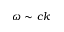Convert formula to latex. <formula><loc_0><loc_0><loc_500><loc_500>\omega \sim c k</formula> 